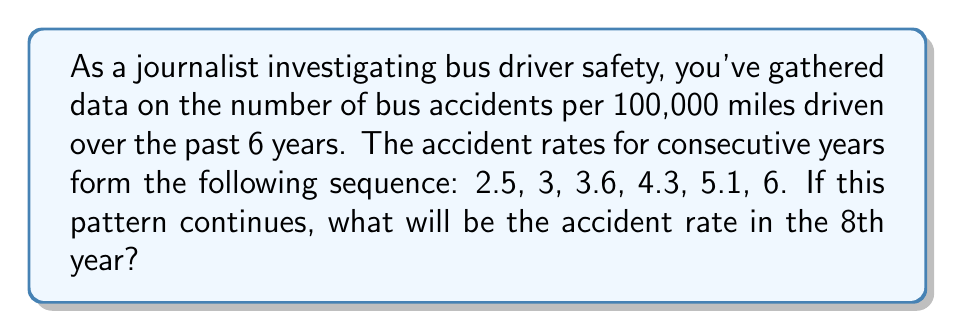What is the answer to this math problem? To solve this problem, we need to identify the pattern in the given sequence and extend it to find the 8th term. Let's approach this step-by-step:

1) First, let's calculate the differences between consecutive terms:

   2.5 → 3 (difference: 0.5)
   3 → 3.6 (difference: 0.6)
   3.6 → 4.3 (difference: 0.7)
   4.3 → 5.1 (difference: 0.8)
   5.1 → 6 (difference: 0.9)

2) We can see that the differences are increasing by 0.1 each time:

   0.5 → 0.6 → 0.7 → 0.8 → 0.9

3) This suggests that the sequence follows a quadratic pattern. The general form of a quadratic sequence is:

   $$a_n = an^2 + bn + c$$

   where $n$ is the term number and $a$, $b$, and $c$ are constants.

4) To find the next two terms, we need to continue the pattern of differences:

   6 → ? (difference: 1.0)
   ? → ? (difference: 1.1)

5) So, the 7th term would be: $6 + 1.0 = 7.0$

6) And the 8th term would be: $7.0 + 1.1 = 8.1$

Therefore, if this pattern continues, the accident rate in the 8th year would be 8.1 per 100,000 miles driven.
Answer: 8.1 